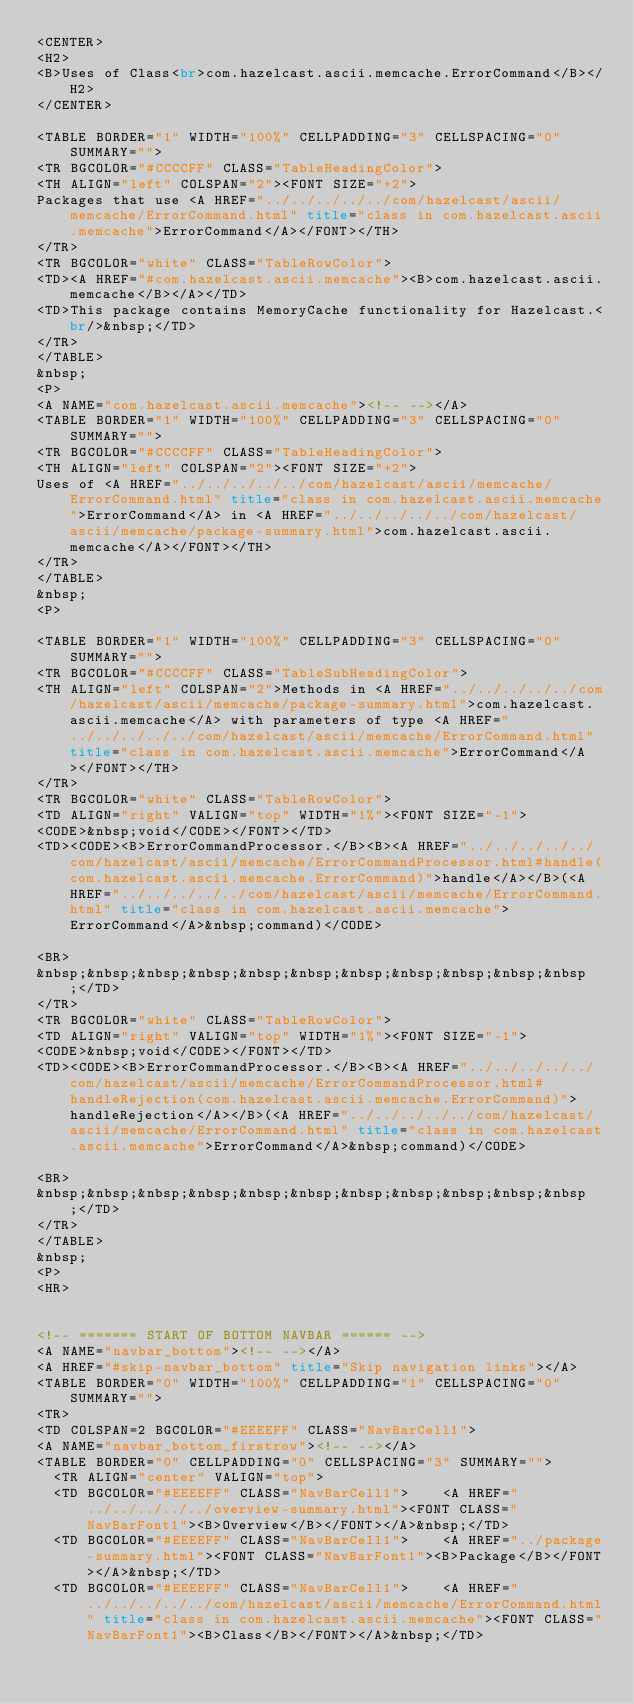<code> <loc_0><loc_0><loc_500><loc_500><_HTML_><CENTER>
<H2>
<B>Uses of Class<br>com.hazelcast.ascii.memcache.ErrorCommand</B></H2>
</CENTER>

<TABLE BORDER="1" WIDTH="100%" CELLPADDING="3" CELLSPACING="0" SUMMARY="">
<TR BGCOLOR="#CCCCFF" CLASS="TableHeadingColor">
<TH ALIGN="left" COLSPAN="2"><FONT SIZE="+2">
Packages that use <A HREF="../../../../../com/hazelcast/ascii/memcache/ErrorCommand.html" title="class in com.hazelcast.ascii.memcache">ErrorCommand</A></FONT></TH>
</TR>
<TR BGCOLOR="white" CLASS="TableRowColor">
<TD><A HREF="#com.hazelcast.ascii.memcache"><B>com.hazelcast.ascii.memcache</B></A></TD>
<TD>This package contains MemoryCache functionality for Hazelcast.<br/>&nbsp;</TD>
</TR>
</TABLE>
&nbsp;
<P>
<A NAME="com.hazelcast.ascii.memcache"><!-- --></A>
<TABLE BORDER="1" WIDTH="100%" CELLPADDING="3" CELLSPACING="0" SUMMARY="">
<TR BGCOLOR="#CCCCFF" CLASS="TableHeadingColor">
<TH ALIGN="left" COLSPAN="2"><FONT SIZE="+2">
Uses of <A HREF="../../../../../com/hazelcast/ascii/memcache/ErrorCommand.html" title="class in com.hazelcast.ascii.memcache">ErrorCommand</A> in <A HREF="../../../../../com/hazelcast/ascii/memcache/package-summary.html">com.hazelcast.ascii.memcache</A></FONT></TH>
</TR>
</TABLE>
&nbsp;
<P>

<TABLE BORDER="1" WIDTH="100%" CELLPADDING="3" CELLSPACING="0" SUMMARY="">
<TR BGCOLOR="#CCCCFF" CLASS="TableSubHeadingColor">
<TH ALIGN="left" COLSPAN="2">Methods in <A HREF="../../../../../com/hazelcast/ascii/memcache/package-summary.html">com.hazelcast.ascii.memcache</A> with parameters of type <A HREF="../../../../../com/hazelcast/ascii/memcache/ErrorCommand.html" title="class in com.hazelcast.ascii.memcache">ErrorCommand</A></FONT></TH>
</TR>
<TR BGCOLOR="white" CLASS="TableRowColor">
<TD ALIGN="right" VALIGN="top" WIDTH="1%"><FONT SIZE="-1">
<CODE>&nbsp;void</CODE></FONT></TD>
<TD><CODE><B>ErrorCommandProcessor.</B><B><A HREF="../../../../../com/hazelcast/ascii/memcache/ErrorCommandProcessor.html#handle(com.hazelcast.ascii.memcache.ErrorCommand)">handle</A></B>(<A HREF="../../../../../com/hazelcast/ascii/memcache/ErrorCommand.html" title="class in com.hazelcast.ascii.memcache">ErrorCommand</A>&nbsp;command)</CODE>

<BR>
&nbsp;&nbsp;&nbsp;&nbsp;&nbsp;&nbsp;&nbsp;&nbsp;&nbsp;&nbsp;&nbsp;</TD>
</TR>
<TR BGCOLOR="white" CLASS="TableRowColor">
<TD ALIGN="right" VALIGN="top" WIDTH="1%"><FONT SIZE="-1">
<CODE>&nbsp;void</CODE></FONT></TD>
<TD><CODE><B>ErrorCommandProcessor.</B><B><A HREF="../../../../../com/hazelcast/ascii/memcache/ErrorCommandProcessor.html#handleRejection(com.hazelcast.ascii.memcache.ErrorCommand)">handleRejection</A></B>(<A HREF="../../../../../com/hazelcast/ascii/memcache/ErrorCommand.html" title="class in com.hazelcast.ascii.memcache">ErrorCommand</A>&nbsp;command)</CODE>

<BR>
&nbsp;&nbsp;&nbsp;&nbsp;&nbsp;&nbsp;&nbsp;&nbsp;&nbsp;&nbsp;&nbsp;</TD>
</TR>
</TABLE>
&nbsp;
<P>
<HR>


<!-- ======= START OF BOTTOM NAVBAR ====== -->
<A NAME="navbar_bottom"><!-- --></A>
<A HREF="#skip-navbar_bottom" title="Skip navigation links"></A>
<TABLE BORDER="0" WIDTH="100%" CELLPADDING="1" CELLSPACING="0" SUMMARY="">
<TR>
<TD COLSPAN=2 BGCOLOR="#EEEEFF" CLASS="NavBarCell1">
<A NAME="navbar_bottom_firstrow"><!-- --></A>
<TABLE BORDER="0" CELLPADDING="0" CELLSPACING="3" SUMMARY="">
  <TR ALIGN="center" VALIGN="top">
  <TD BGCOLOR="#EEEEFF" CLASS="NavBarCell1">    <A HREF="../../../../../overview-summary.html"><FONT CLASS="NavBarFont1"><B>Overview</B></FONT></A>&nbsp;</TD>
  <TD BGCOLOR="#EEEEFF" CLASS="NavBarCell1">    <A HREF="../package-summary.html"><FONT CLASS="NavBarFont1"><B>Package</B></FONT></A>&nbsp;</TD>
  <TD BGCOLOR="#EEEEFF" CLASS="NavBarCell1">    <A HREF="../../../../../com/hazelcast/ascii/memcache/ErrorCommand.html" title="class in com.hazelcast.ascii.memcache"><FONT CLASS="NavBarFont1"><B>Class</B></FONT></A>&nbsp;</TD></code> 